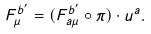<formula> <loc_0><loc_0><loc_500><loc_500>F _ { \mu } ^ { b ^ { \prime } } = ( F _ { a \mu } ^ { b ^ { \prime } } \circ \pi ) \cdot u ^ { a } .</formula> 